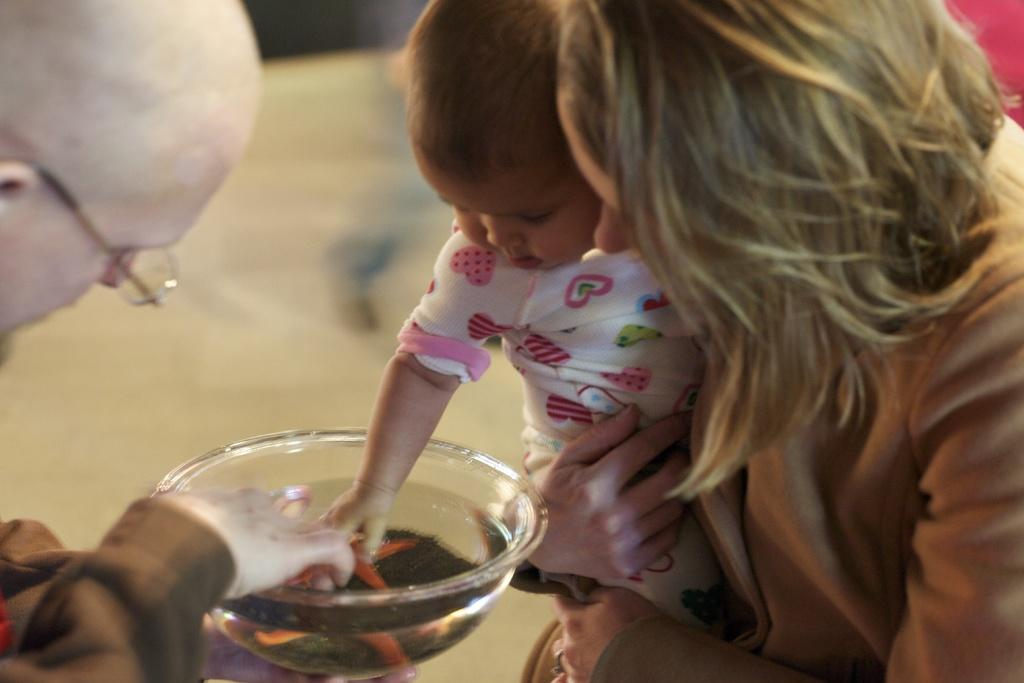What is the woman doing on the right side of the image? The woman is holding a baby on the right side of the image. What is the man doing on the left side of the image? The man is holding a bowl on the left side of the image. Can you describe the relationship between the woman and the baby? The woman is likely the baby's mother or caretaker, as she is holding the baby. What might the man be doing with the bowl? The man might be preparing food or serving a meal with the bowl. What type of wall can be seen in the image? There is no wall present in the image; it features a woman holding a baby and a man holding a bowl. 